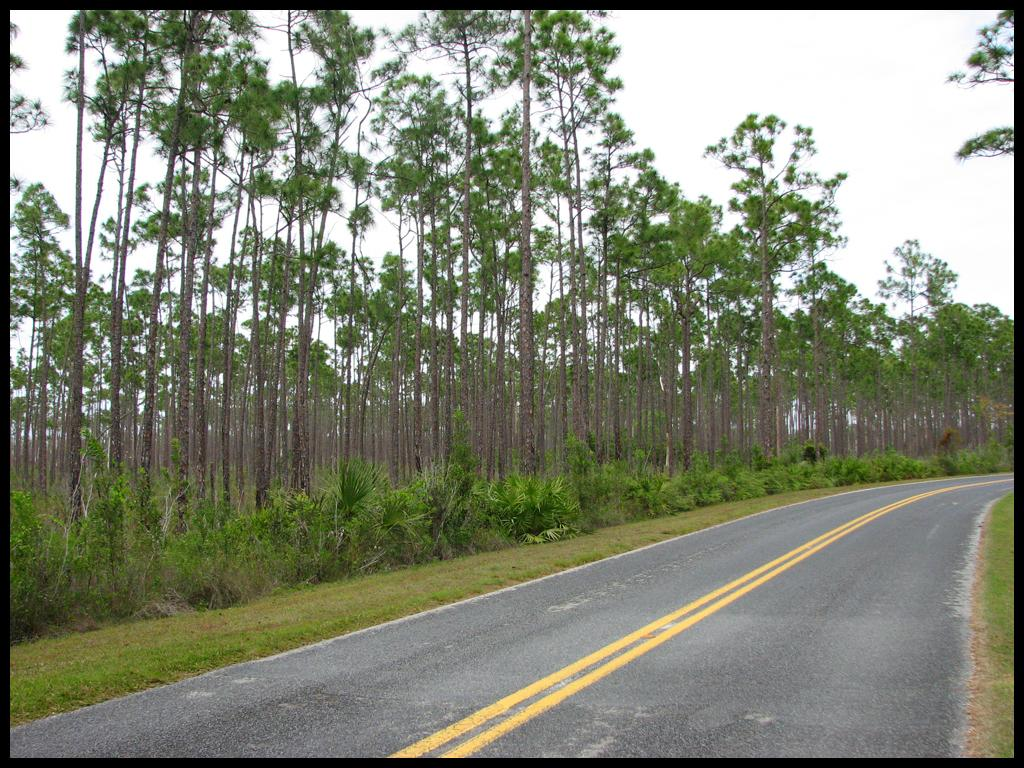What is the main feature of the image? There is a road in the image. What type of vegetation can be seen in the image? There are green color plants and trees in the image. What is visible at the top of the image? The sky is visible at the top of the image. What type of hook can be seen hanging from the trees in the image? There is no hook present in the image; it features a road, green color plants, trees, and the sky. 